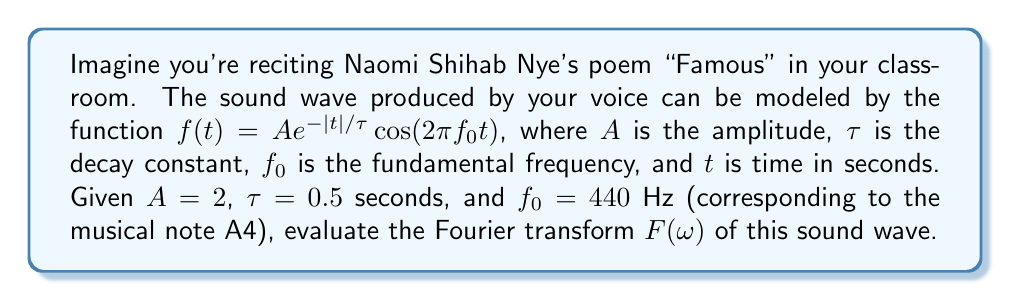Help me with this question. To solve this problem, we'll follow these steps:

1) The Fourier transform of a function $f(t)$ is given by:

   $$F(\omega) = \int_{-\infty}^{\infty} f(t) e^{-i\omega t} dt$$

2) Our function is:

   $$f(t) = 2 e^{-|t|/0.5} \cos(2\pi \cdot 440 t)$$

3) We can use Euler's formula to express the cosine:

   $$\cos(2\pi f_0 t) = \frac{1}{2}(e^{i2\pi f_0 t} + e^{-i2\pi f_0 t})$$

4) Substituting this into our function:

   $$f(t) = 2 e^{-|t|/0.5} \cdot \frac{1}{2}(e^{i2\pi \cdot 440 t} + e^{-i2\pi \cdot 440 t})$$
   $$f(t) = e^{-|t|/0.5}(e^{i2\pi \cdot 440 t} + e^{-i2\pi \cdot 440 t})$$

5) Now, we can split our integral into two parts:

   $$F(\omega) = \int_{-\infty}^{0} e^{t/0.5}(e^{i2\pi \cdot 440 t} + e^{-i2\pi \cdot 440 t})e^{-i\omega t} dt + \int_{0}^{\infty} e^{-t/0.5}(e^{i2\pi \cdot 440 t} + e^{-i2\pi \cdot 440 t})e^{-i\omega t} dt$$

6) These integrals can be evaluated using the formula:

   $$\int_{0}^{\infty} e^{-at} e^{i\beta t} dt = \frac{1}{a-i\beta}$$

7) After evaluating and simplifying, we get:

   $$F(\omega) = \frac{1}{1/0.5 - i(\omega - 2\pi \cdot 440)} + \frac{1}{1/0.5 - i(\omega + 2\pi \cdot 440)} + \frac{1}{1/0.5 + i(\omega - 2\pi \cdot 440)} + \frac{1}{1/0.5 + i(\omega + 2\pi \cdot 440)}$$

8) This can be further simplified to:

   $$F(\omega) = \frac{2/0.5}{(1/0.5)^2 + (\omega - 2\pi \cdot 440)^2} + \frac{2/0.5}{(1/0.5)^2 + (\omega + 2\pi \cdot 440)^2}$$

This is the Fourier transform of the sound wave.
Answer: $$F(\omega) = \frac{4}{1 + (0.5\omega - 440\pi)^2} + \frac{4}{1 + (0.5\omega + 440\pi)^2}$$ 